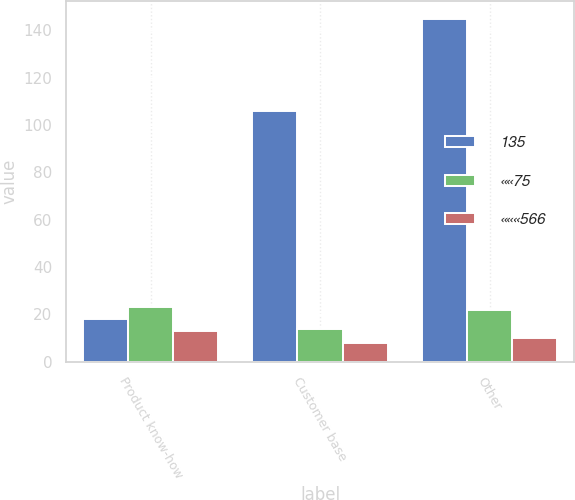Convert chart to OTSL. <chart><loc_0><loc_0><loc_500><loc_500><stacked_bar_chart><ecel><fcel>Product know-how<fcel>Customer base<fcel>Other<nl><fcel>135<fcel>18<fcel>106<fcel>145<nl><fcel>««75<fcel>23<fcel>14<fcel>22<nl><fcel>«««566<fcel>13<fcel>8<fcel>10<nl></chart> 